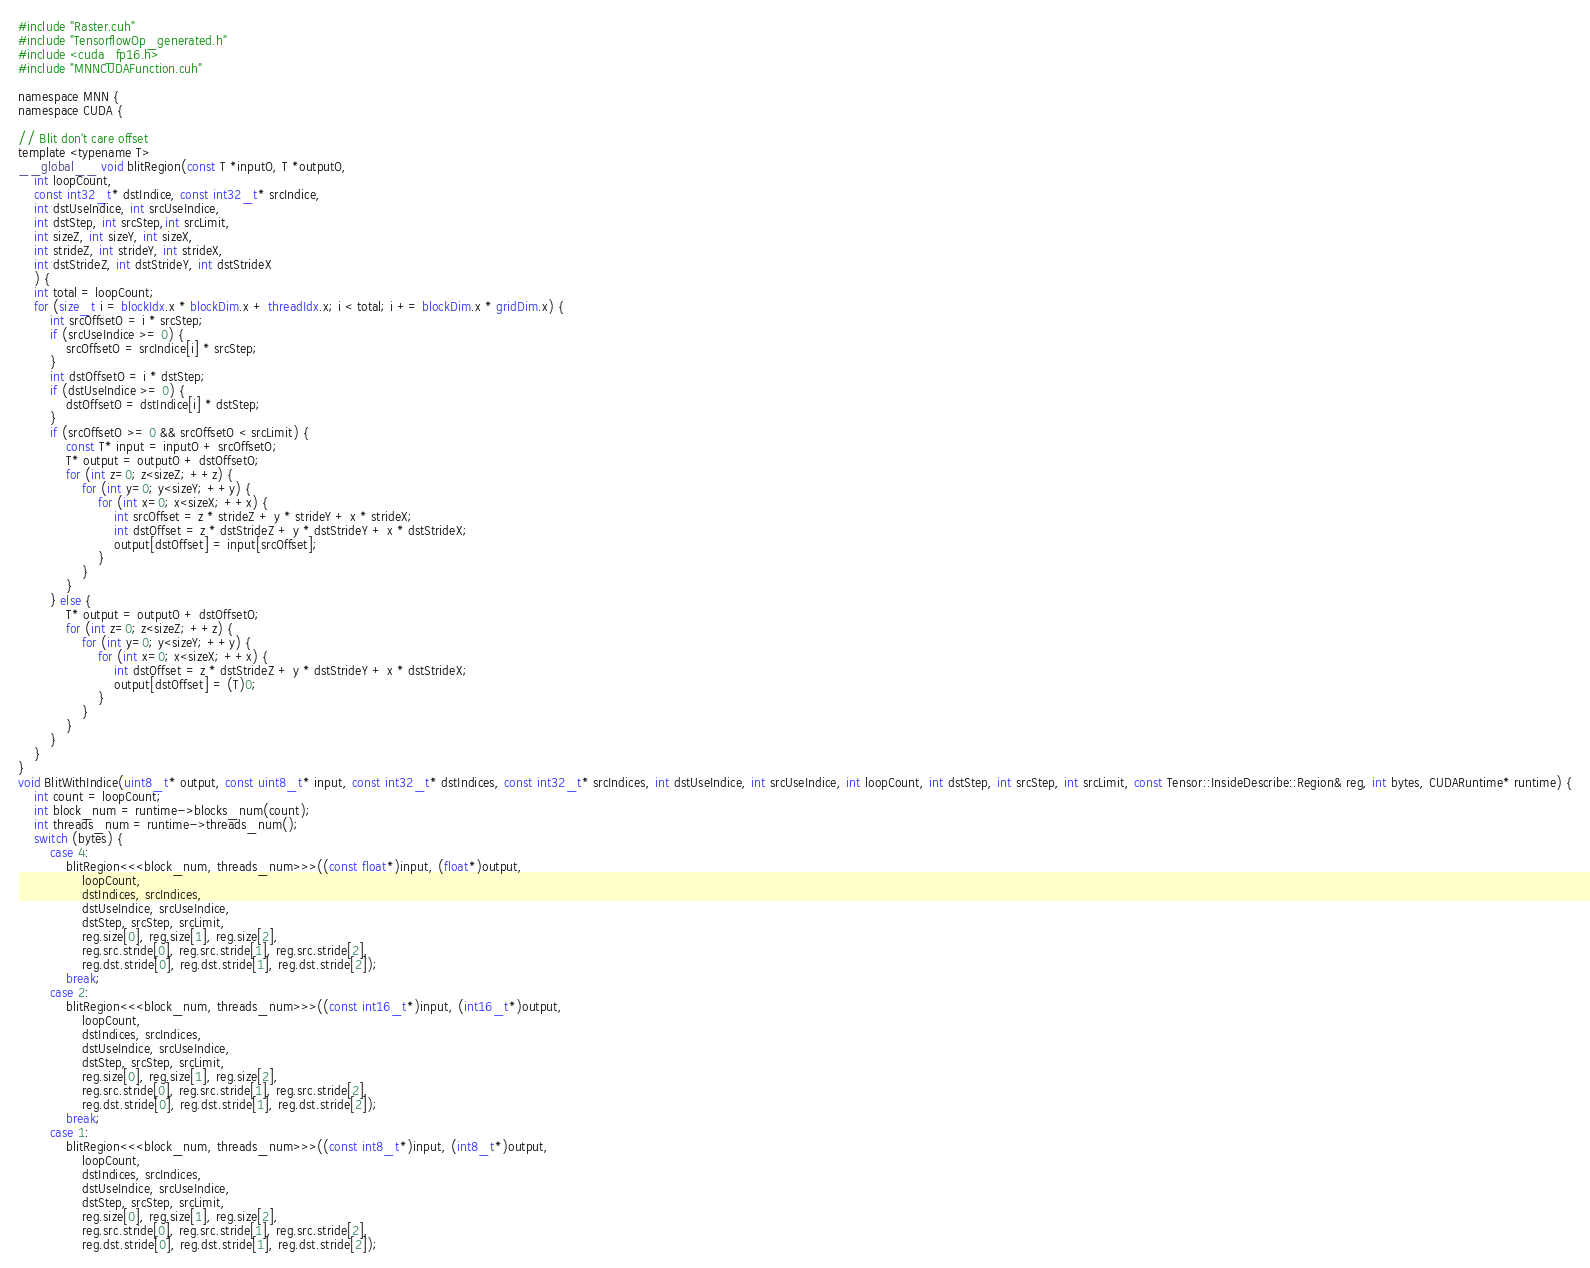<code> <loc_0><loc_0><loc_500><loc_500><_Cuda_>#include "Raster.cuh"
#include "TensorflowOp_generated.h"
#include <cuda_fp16.h>
#include "MNNCUDAFunction.cuh"

namespace MNN {
namespace CUDA {

// Blit don't care offset
template <typename T>
__global__ void blitRegion(const T *inputO, T *outputO,
    int loopCount,
    const int32_t* dstIndice, const int32_t* srcIndice,
    int dstUseIndice, int srcUseIndice,
    int dstStep, int srcStep,int srcLimit,
    int sizeZ, int sizeY, int sizeX,
    int strideZ, int strideY, int strideX,
    int dstStrideZ, int dstStrideY, int dstStrideX
    ) {
    int total = loopCount;
    for (size_t i = blockIdx.x * blockDim.x + threadIdx.x; i < total; i += blockDim.x * gridDim.x) {
        int srcOffsetO = i * srcStep;
        if (srcUseIndice >= 0) {
            srcOffsetO = srcIndice[i] * srcStep;
        }
        int dstOffsetO = i * dstStep;
        if (dstUseIndice >= 0) {
            dstOffsetO = dstIndice[i] * dstStep;
        }
        if (srcOffsetO >= 0 && srcOffsetO < srcLimit) {
            const T* input = inputO + srcOffsetO;
            T* output = outputO + dstOffsetO;
            for (int z=0; z<sizeZ; ++z) {
                for (int y=0; y<sizeY; ++y) {
                    for (int x=0; x<sizeX; ++x) {
                        int srcOffset = z * strideZ + y * strideY + x * strideX;
                        int dstOffset = z * dstStrideZ + y * dstStrideY + x * dstStrideX;
                        output[dstOffset] = input[srcOffset];
                    }
                }
            }
        } else {
            T* output = outputO + dstOffsetO;
            for (int z=0; z<sizeZ; ++z) {
                for (int y=0; y<sizeY; ++y) {
                    for (int x=0; x<sizeX; ++x) {
                        int dstOffset = z * dstStrideZ + y * dstStrideY + x * dstStrideX;
                        output[dstOffset] = (T)0;
                    }
                }
            }
        }
    }
}
void BlitWithIndice(uint8_t* output, const uint8_t* input, const int32_t* dstIndices, const int32_t* srcIndices, int dstUseIndice, int srcUseIndice, int loopCount, int dstStep, int srcStep, int srcLimit, const Tensor::InsideDescribe::Region& reg, int bytes, CUDARuntime* runtime) {
    int count = loopCount;
    int block_num = runtime->blocks_num(count);
    int threads_num = runtime->threads_num();
    switch (bytes) {
        case 4:
            blitRegion<<<block_num, threads_num>>>((const float*)input, (float*)output, 
                loopCount,
                dstIndices, srcIndices,
                dstUseIndice, srcUseIndice,
                dstStep, srcStep, srcLimit,
                reg.size[0], reg.size[1], reg.size[2],
                reg.src.stride[0], reg.src.stride[1], reg.src.stride[2],
                reg.dst.stride[0], reg.dst.stride[1], reg.dst.stride[2]);
            break;
        case 2:
            blitRegion<<<block_num, threads_num>>>((const int16_t*)input, (int16_t*)output,
                loopCount,
                dstIndices, srcIndices,
                dstUseIndice, srcUseIndice,
                dstStep, srcStep, srcLimit,
                reg.size[0], reg.size[1], reg.size[2],
                reg.src.stride[0], reg.src.stride[1], reg.src.stride[2],
                reg.dst.stride[0], reg.dst.stride[1], reg.dst.stride[2]);
            break;
        case 1:
            blitRegion<<<block_num, threads_num>>>((const int8_t*)input, (int8_t*)output,
                loopCount,
                dstIndices, srcIndices,
                dstUseIndice, srcUseIndice,
                dstStep, srcStep, srcLimit,
                reg.size[0], reg.size[1], reg.size[2],
                reg.src.stride[0], reg.src.stride[1], reg.src.stride[2],
                reg.dst.stride[0], reg.dst.stride[1], reg.dst.stride[2]);</code> 